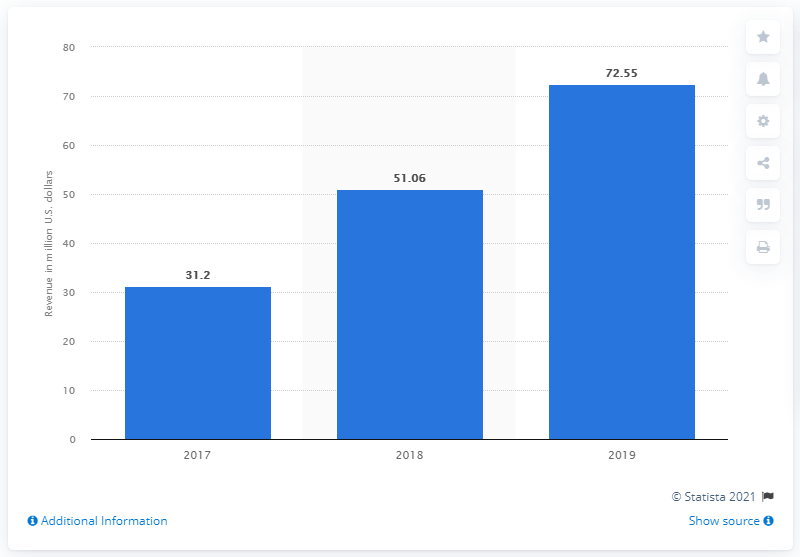Specify some key components in this picture. Stitcher's revenue in the previous year was approximately 51.06. Stitcher generated approximately $72.55 million in revenue in 2019. 